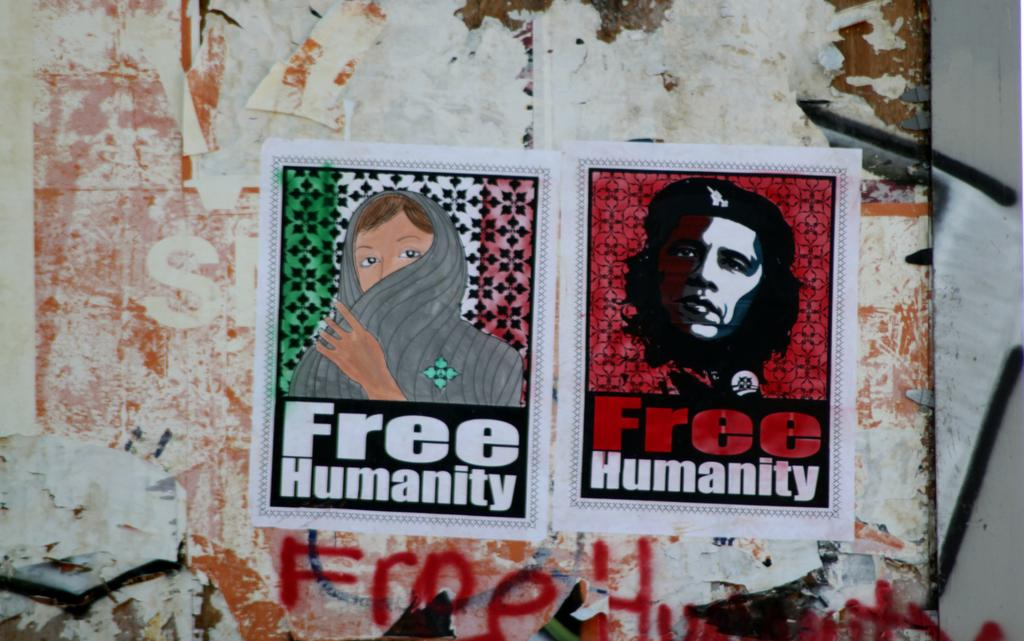What is the main object in the image? There is a board in the image. What is on the board? There is a poster on the board. What can be seen in the background of the image? There is a wall in the background of the image. How many sheets are used to create the poster on the board? There is no information about the number of sheets used to create the poster on the board. 